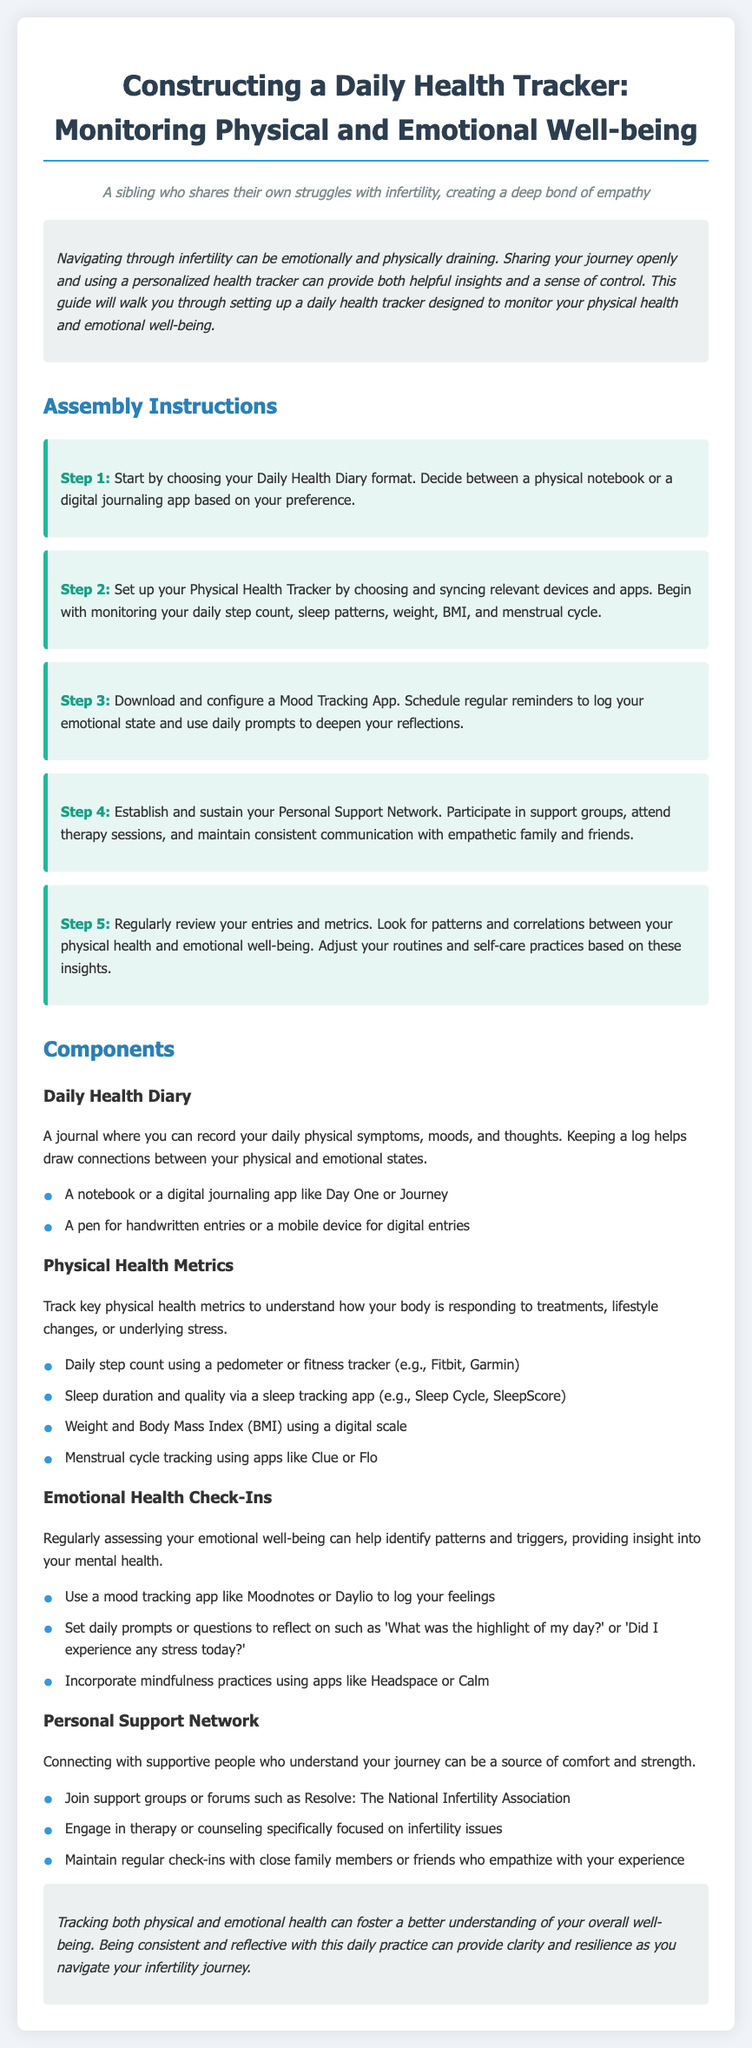what is the title of the document? The title of the document is presented at the top in a prominent manner.
Answer: Constructing a Daily Health Tracker: Monitoring Physical and Emotional Well-being how many steps are in the assembly instructions? The assembly instructions section lists all the steps needed to construct the health tracker.
Answer: 5 what should be used to track daily steps? This is specified in the Physical Health Metrics section that mentions tracking devices and apps.
Answer: Pedometer or fitness tracker what mood tracking app is recommended? The document mentions specific apps for logging emotional states in the Emotional Health Check-Ins section.
Answer: Moodnotes or Daylio what is the purpose of keeping a Daily Health Diary? The document explains the significance of maintaining this diary in one of the components sections.
Answer: To record daily physical symptoms, moods, and thoughts which group is suggested for building a personal support network? In the Personal Support Network section, the document mentions a specific organization focused on infertility.
Answer: Resolve: The National Infertility Association what type of prompt is recommended for mood tracking? This is discussed under the Emotional Health Check-Ins section about how to facilitate reflections.
Answer: Daily prompts or questions what should be regularly reviewed for insights? The conclusion indicates the continuous activity that can foster understanding of overall well-being.
Answer: Entries and metrics 